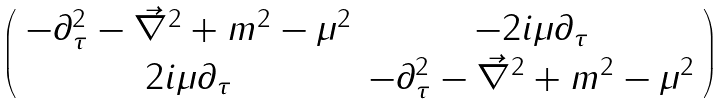<formula> <loc_0><loc_0><loc_500><loc_500>\left ( \begin{array} { c c } { - \partial _ { \tau } ^ { 2 } - \vec { \nabla } ^ { 2 } + m ^ { 2 } - \mu ^ { 2 } } & { - 2 i \mu \partial _ { \tau } } \\ { 2 i \mu \partial _ { \tau } } & { - \partial _ { \tau } ^ { 2 } - \vec { \nabla } ^ { 2 } + m ^ { 2 } - \mu ^ { 2 } } \end{array} \right )</formula> 